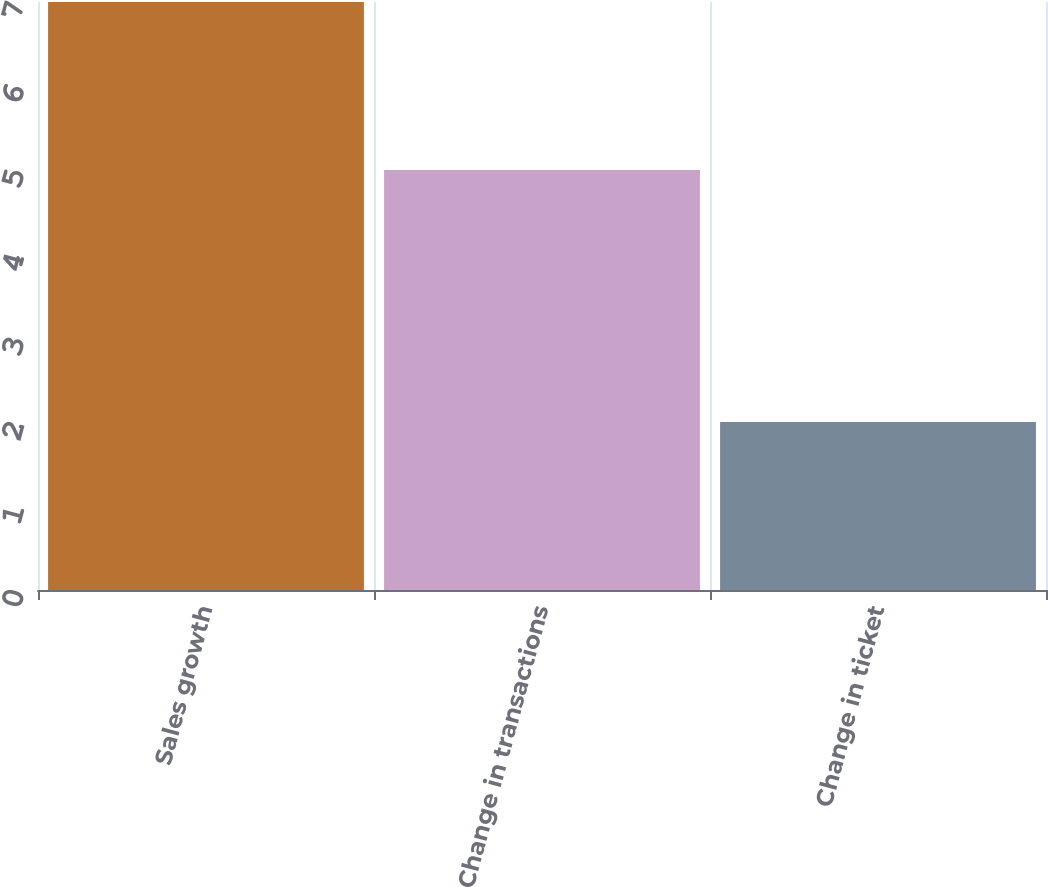<chart> <loc_0><loc_0><loc_500><loc_500><bar_chart><fcel>Sales growth<fcel>Change in transactions<fcel>Change in ticket<nl><fcel>7<fcel>5<fcel>2<nl></chart> 